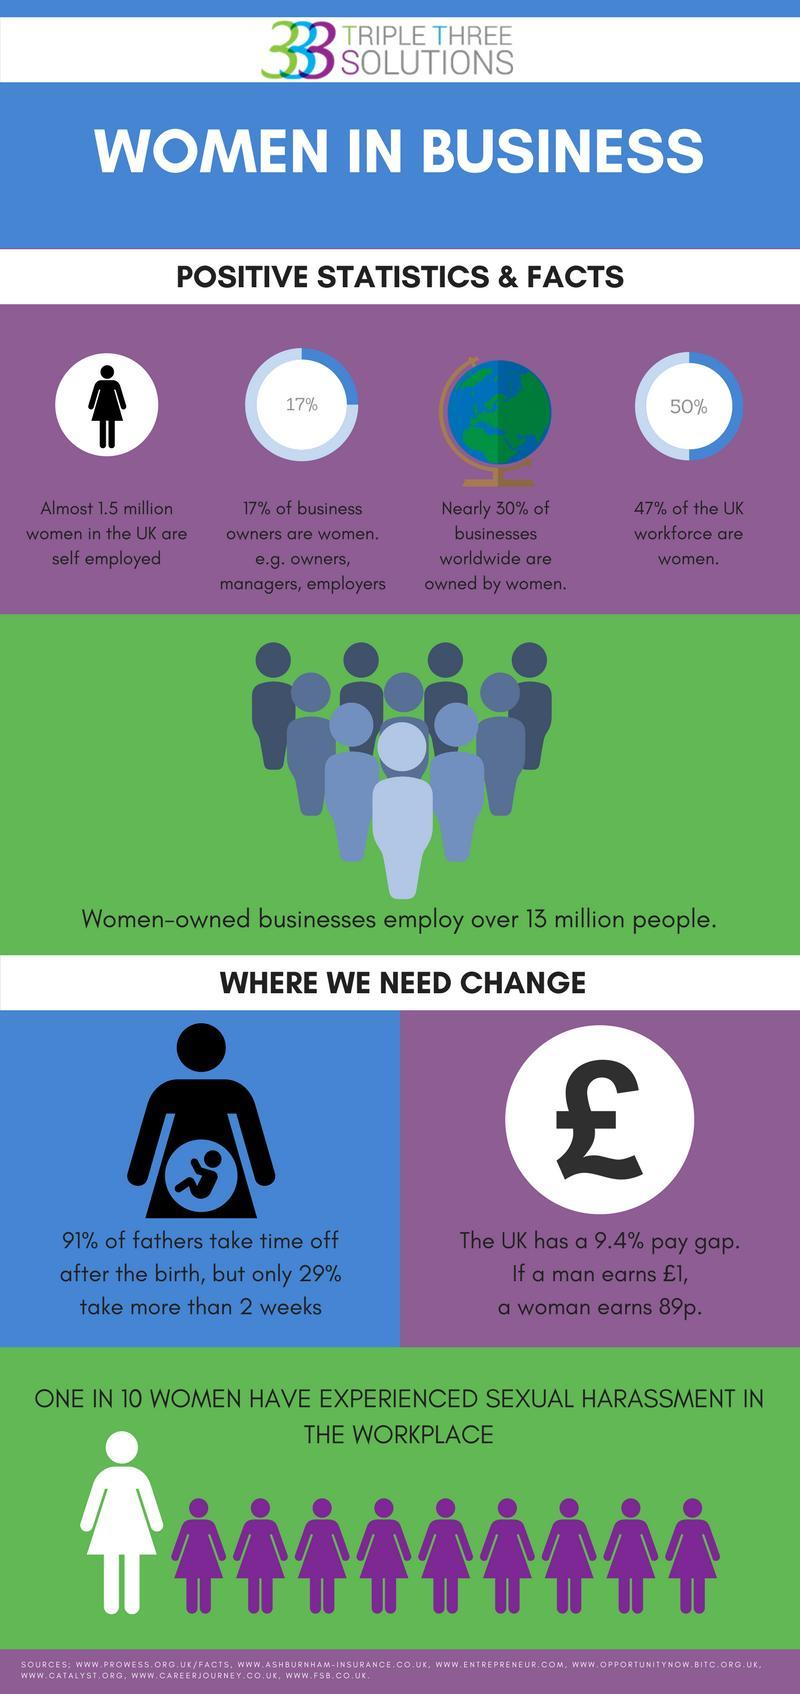What percentage of the UK workforce are not women?
Answer the question with a short phrase. 53% Out of 10, how many women never experienced sexual harassment in the workplace? 9 What percentage of business owners are not women? 83% 